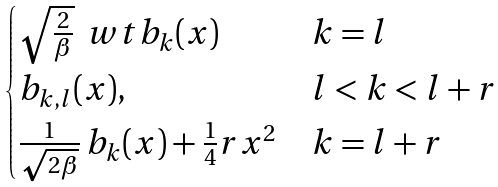<formula> <loc_0><loc_0><loc_500><loc_500>\begin{cases} \sqrt { \frac { 2 } { \beta } } \, \ w t b _ { k } ( x ) & k = l \\ b _ { k , l } ( x ) , & l < k < l + r \\ \frac { 1 } { \sqrt { 2 \beta } } \, b _ { k } ( x ) + \frac { 1 } { 4 } r x ^ { 2 } & k = l + r \end{cases}</formula> 